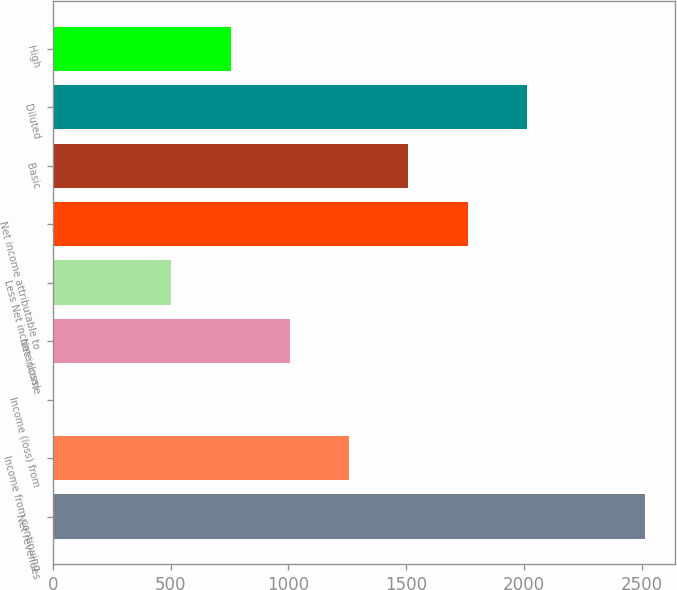<chart> <loc_0><loc_0><loc_500><loc_500><bar_chart><fcel>Net revenues<fcel>Income from continuing<fcel>Income (loss) from<fcel>Net income<fcel>Less Net income (loss)<fcel>Net income attributable to<fcel>Basic<fcel>Diluted<fcel>High<nl><fcel>2514<fcel>1257.5<fcel>1<fcel>1006.2<fcel>503.6<fcel>1760.1<fcel>1508.8<fcel>2011.4<fcel>754.9<nl></chart> 